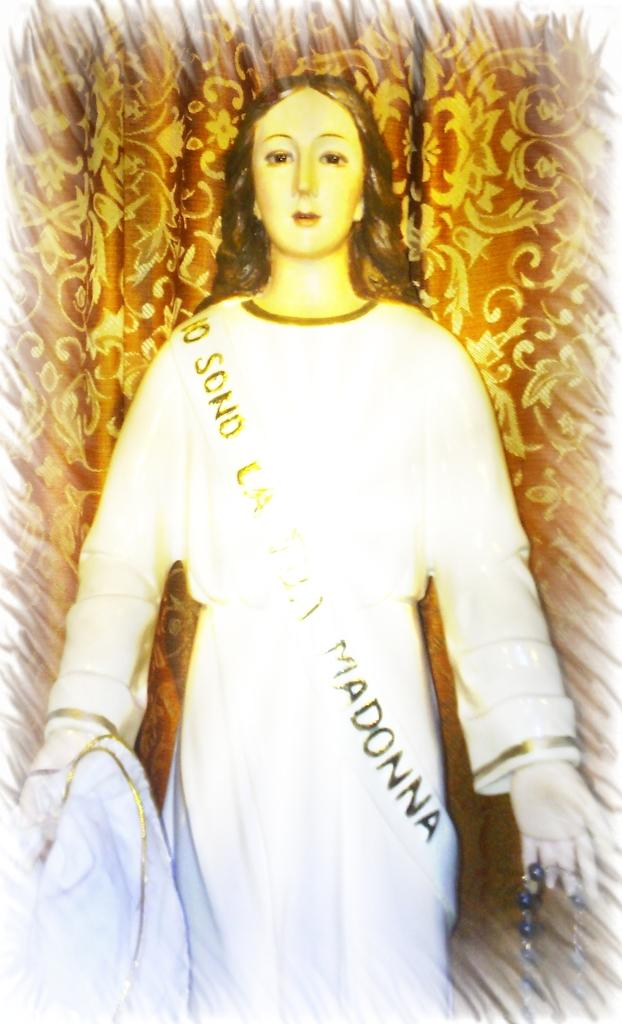What is the main subject of the image? There is a statue of a person in the image. What can be observed about the statue's appearance? The statue is of a person. What is the color of the background in the image? The background of the image is brown in color. How many horses are depicted in the image? There are no horses present in the image; it features a statue of a person. What type of egg is visible in the image? There is no egg present in the image. 